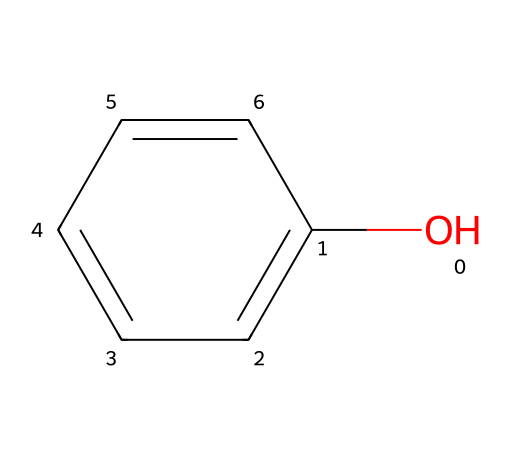What is the molecular formula of the compound? By analyzing the structure from the SMILES notation, we can count the number of carbon (C), hydrogen (H), and oxygen (O) atoms present. There are six carbon atoms, six hydrogen atoms, and one oxygen atom, leading to the molecular formula C6H6O.
Answer: C6H6O How many carbon atoms are in the structure? The structure represented by the SMILES notation has a six-membered carbon ring (the "c" indicates aromatic carbons), indicating there are six carbon atoms in total.
Answer: six What functional group is present in this compound? The presence of the hydroxyl group (-OH) attached to the aromatic ring in the structure denotes that the compound is a phenol, giving it characteristic properties and reactivity.
Answer: hydroxyl group Is this compound a strong or weak disinfectant? Phenol and its derivatives are known for being effective disinfectants; however, they can vary in strength. Generally, this compound is regarded as a medium-strength disinfectant compared to others.
Answer: medium-strength What type of chemical is this compound classified as? This compound contains an aromatic ring and a hydroxyl group, classifying it as a phenol, which is specifically noted for its antiseptic and disinfectant properties.
Answer: phenol What is the primary use of phenolic compounds in hotels? Phenolic compounds like this one are primarily used for their disinfectant properties, making them suitable for cleaning surfaces and sanitizing areas in hotels.
Answer: disinfectant 